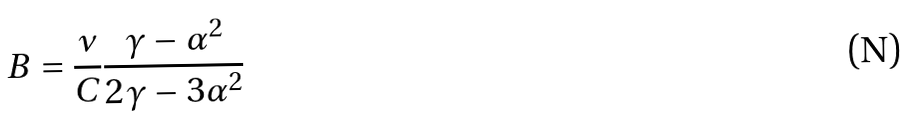Convert formula to latex. <formula><loc_0><loc_0><loc_500><loc_500>B = \frac { \nu } { C } \frac { \gamma - \alpha ^ { 2 } } { 2 \gamma - 3 \alpha ^ { 2 } }</formula> 